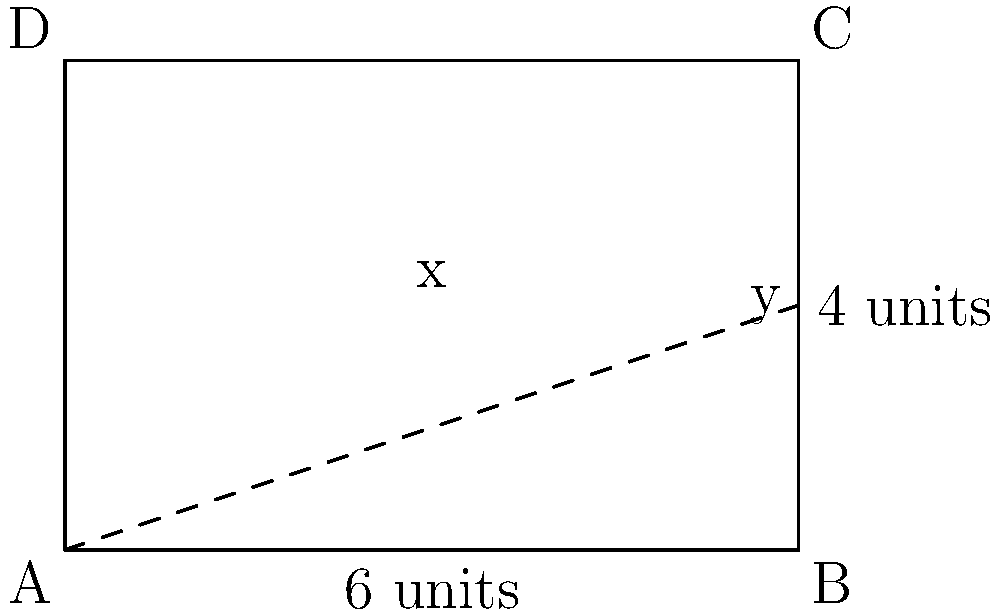As a security guard, you need to patrol a rectangular perimeter of dimensions 6 units by 4 units. To minimize the use of digital technology, you want to calculate the most efficient route manually. If you start at corner A and need to check a point (x, y) inside the rectangle before completing your route, what values of x and y will minimize the total distance traveled? Let's approach this step-by-step:

1) The total distance traveled will be the sum of:
   - Distance from A to (x, y)
   - Distance from (x, y) to C
   - Distance from C back to A along the perimeter

2) We can express this distance as a function:
   $$D(x,y) = \sqrt{x^2 + y^2} + \sqrt{(6-x)^2 + (4-y)^2} + 10$$

3) To find the minimum, we need to find where the partial derivatives with respect to x and y are both zero:

   $$\frac{\partial D}{\partial x} = \frac{x}{\sqrt{x^2 + y^2}} - \frac{6-x}{\sqrt{(6-x)^2 + (4-y)^2}} = 0$$
   
   $$\frac{\partial D}{\partial y} = \frac{y}{\sqrt{x^2 + y^2}} - \frac{4-y}{\sqrt{(6-x)^2 + (4-y)^2}} = 0$$

4) These equations are satisfied when:
   $$\frac{x}{6-x} = \frac{y}{4-y}$$

5) This occurs when the point (x, y) is on the diagonal of the rectangle.

6) Given the symmetry of the problem, the optimal point will be at the center of the rectangle.

7) Therefore, x = 3 and y = 2.
Answer: x = 3, y = 2 